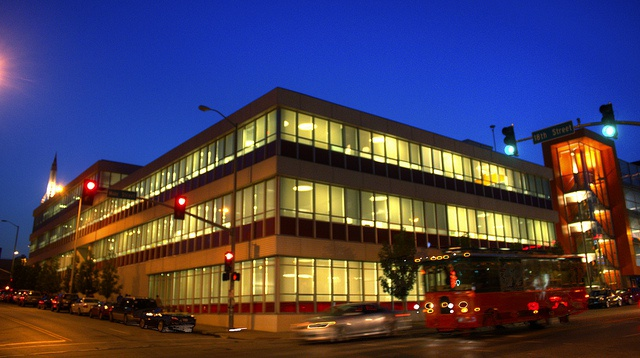Describe the objects in this image and their specific colors. I can see bus in darkblue, black, maroon, and olive tones, car in darkblue, maroon, black, and brown tones, car in darkblue, black, maroon, and brown tones, car in darkblue, black, maroon, brown, and gray tones, and traffic light in darkblue, black, teal, white, and cyan tones in this image. 